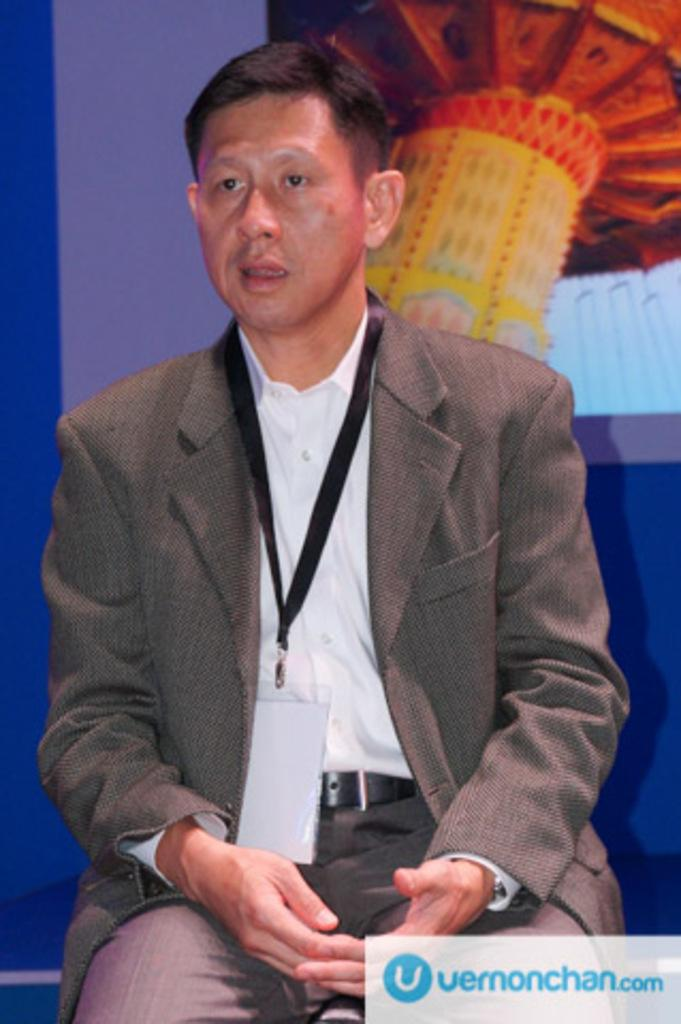What is the person in the image doing? The person is sitting on a sofa set in the image. Can you describe the background of the image? The background of the image is colorful. What type of fear can be seen on the person's face in the image? There is no indication of fear on the person's face in the image. How many pigs are visible in the image? There are no pigs present in the image. What type of grape is being eaten by the person in the image? There is no grape present in the image. 